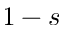Convert formula to latex. <formula><loc_0><loc_0><loc_500><loc_500>1 - s</formula> 